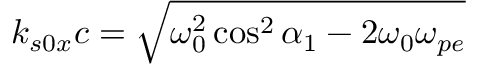<formula> <loc_0><loc_0><loc_500><loc_500>k _ { s 0 x } c = \sqrt { \omega _ { 0 } ^ { 2 } \cos ^ { 2 } \alpha _ { 1 } - 2 \omega _ { 0 } \omega _ { p e } }</formula> 